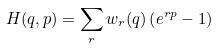Convert formula to latex. <formula><loc_0><loc_0><loc_500><loc_500>H ( q , p ) = \sum _ { r } w _ { r } ( q ) \left ( e ^ { r p } - 1 \right )</formula> 